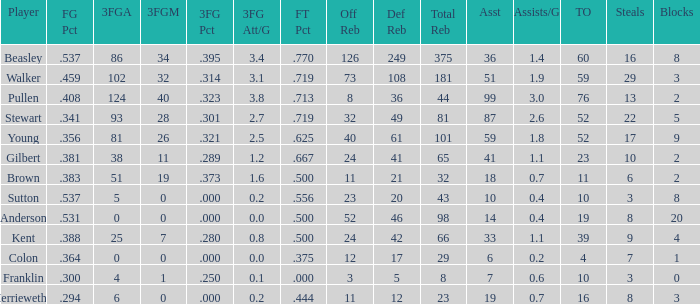What is the total number of offensive rebounds for players with under 65 total rebounds, 5 defensive rebounds, and under 7 assists? 0.0. 